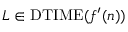Convert formula to latex. <formula><loc_0><loc_0><loc_500><loc_500>L \in D T I M E ( f ^ { \prime } ( n ) )</formula> 